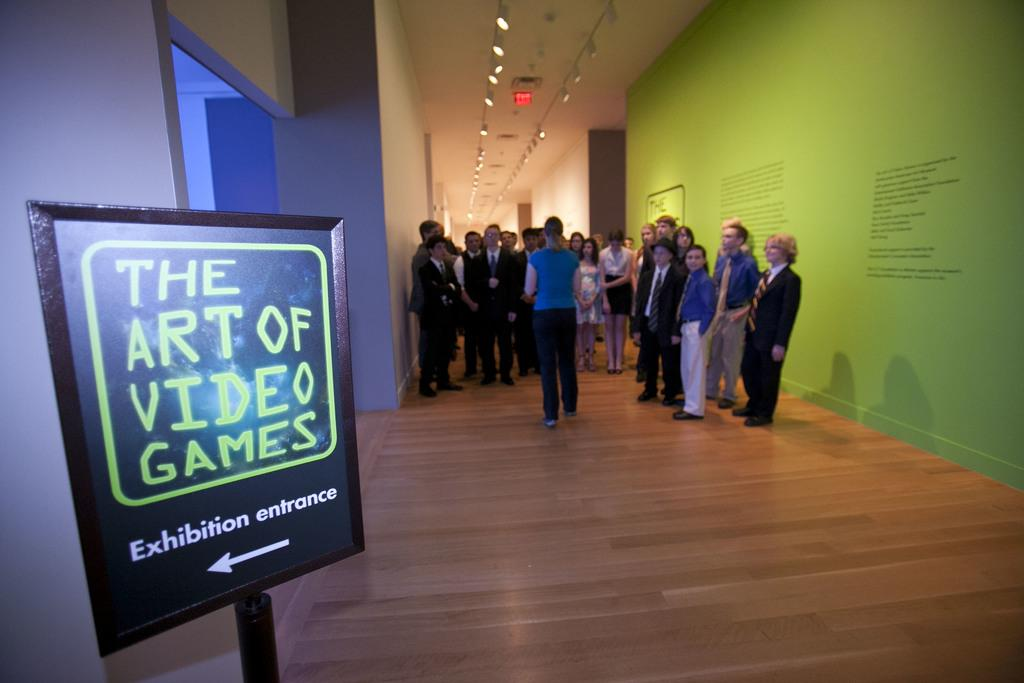Provide a one-sentence caption for the provided image. The Art of Video Games Exhibition entrance is to the left. 